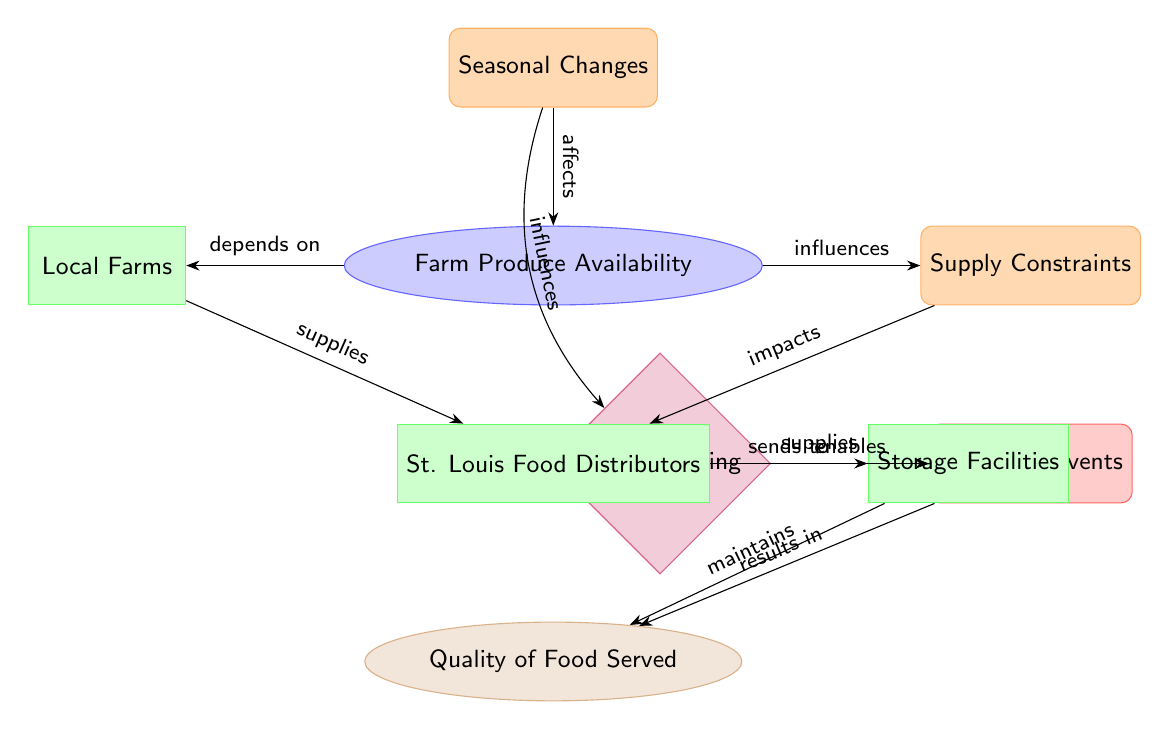What affects Farm Produce Availability? According to the diagram, Seasonal Changes directly affect Farm Produce Availability. This relationship is shown by the arrow pointing from Seasonal Changes to Farm Produce Availability, labeled "affects."
Answer: Seasonal Changes What influences Supply Constraints? The diagram indicates that Farm Produce Availability influences Supply Constraints. The arrow going from Farm Produce Availability to Supply Constraints is labeled "influences."
Answer: Farm Produce Availability How many entities are present in the diagram? The diagram contains a total of five entities: Local Farms, St. Louis Food Distributors, Storage Facilities, Menu Planning, and University Events. By counting the boxes representing entities, we find there are five.
Answer: 5 What is supplied by St. Louis Food Distributors? St. Louis Food Distributors supply food to University Events, as indicated by the arrow labeled "supplies" flowing from St. Louis Food Distributors to University Events.
Answer: University Events What is the output of the diagram? The final output indicated in the diagram is the Quality of Food Served, which is reached through several preceding nodes. The last node in the flow shows this output clearly.
Answer: Quality of Food Served What maintains the Quality of Food Served? The Storage Facilities maintain the Quality of Food Served, as depicted by the arrow labeled "maintains" that flows from Storage Facilities to Quality of Food Served.
Answer: Storage Facilities Which factor influences Menu Planning? The diagram shows that Seasonal Changes influence Menu Planning through an arrow that indicates this relationship, labeled "influences," indicating that the seasonal aspect affects how menus are planned.
Answer: Seasonal Changes What impacts Farm Produce Availability? Supply Constraints impact Farm Produce Availability. This is illustrated with an arrow pointing from Supply Constraints to Farm Produce Availability labeled "impacts," showing the directional influence of the constraints on availability.
Answer: Supply Constraints How do Local Farms contribute to the supply chain? Local Farms contribute by supplying farm produce to St. Louis Food Distributors, as shown by the arrow labeled "supplies" that connects Local Farms and St. Louis Food Distributors.
Answer: Farm Produce 